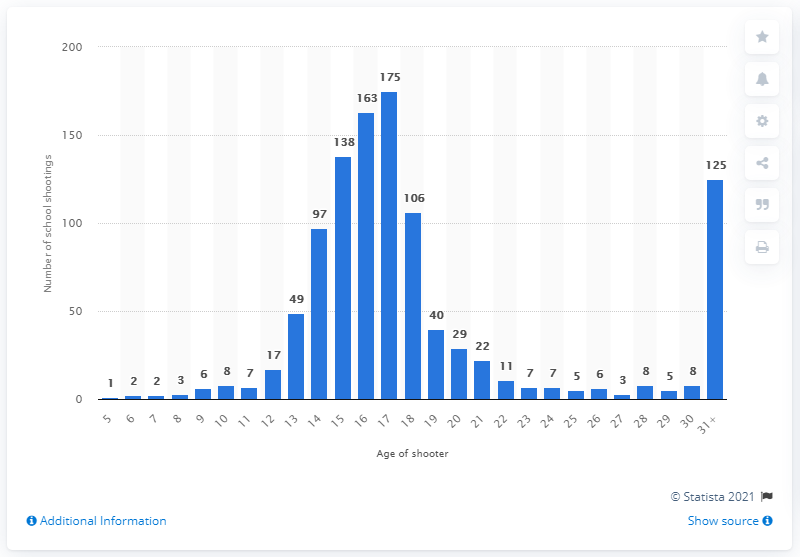Draw attention to some important aspects in this diagram. There were 163 school shootings committed by 16-year-olds between 1970 and 2020. In the period between 1970 and 2020, 17-year-olds were responsible for a significant number of school shootings. 